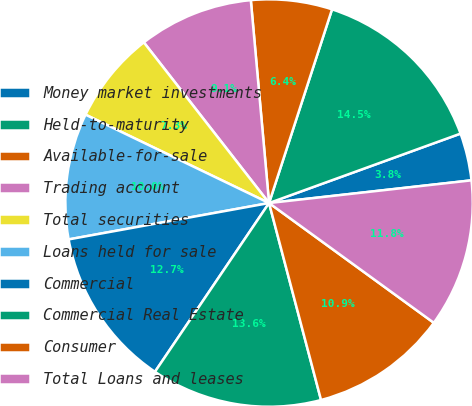<chart> <loc_0><loc_0><loc_500><loc_500><pie_chart><fcel>Money market investments<fcel>Held-to-maturity<fcel>Available-for-sale<fcel>Trading account<fcel>Total securities<fcel>Loans held for sale<fcel>Commercial<fcel>Commercial Real Estate<fcel>Consumer<fcel>Total Loans and leases<nl><fcel>3.76%<fcel>14.46%<fcel>6.43%<fcel>9.11%<fcel>7.32%<fcel>10.0%<fcel>12.68%<fcel>13.57%<fcel>10.89%<fcel>11.78%<nl></chart> 